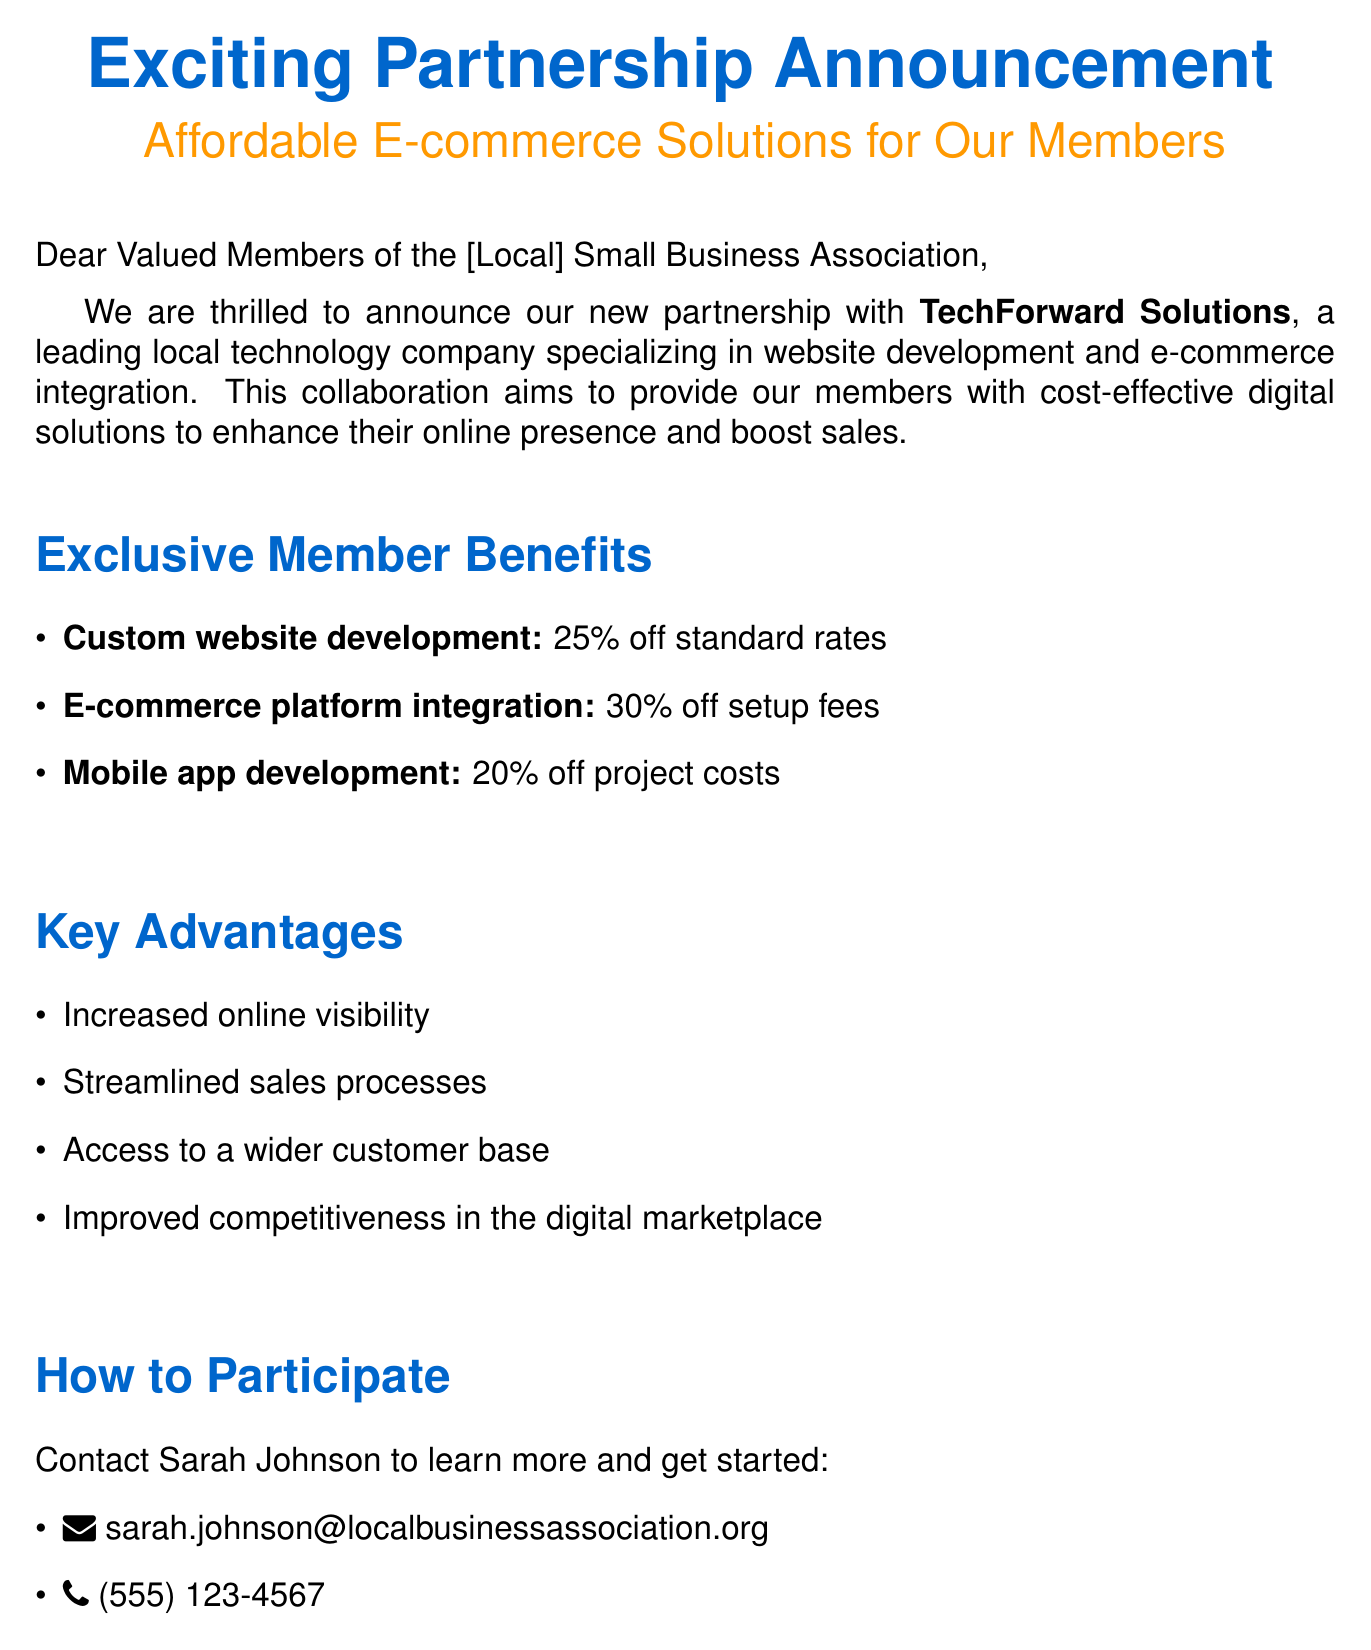What is the name of the partner company? The partner company mentioned in the document is TechForward Solutions.
Answer: TechForward Solutions What discount is offered for custom website development? The document states a 25% discount on standard rates for custom website development.
Answer: 25% off What is the date of the upcoming E-commerce Integration Workshop? The document specifies the date of the workshop as July 15, 2023.
Answer: July 15, 2023 Who should members contact for more information? The document indicates that members should contact Sarah Johnson for more information.
Answer: Sarah Johnson What are two benefits for members mentioned in the document? The document lists four benefits, including increased online visibility and improved competitiveness in the digital marketplace.
Answer: Increased online visibility, improved competitiveness in the digital marketplace What services are included in the partnership offerings? The document details three specific services: custom website development, e-commerce platform integration, and mobile app development.
Answer: Custom website development, e-commerce platform integration, mobile app development What time is the E-commerce Integration Workshop scheduled to start? The document specifies that the workshop begins at 2:00 PM.
Answer: 2:00 PM What is the goal of the partnership with TechForward Solutions? The partnership's goal is to provide cost-effective digital solutions to enhance online presence and boost sales for members.
Answer: Cost-effective digital solutions to enhance online presence and boost sales 